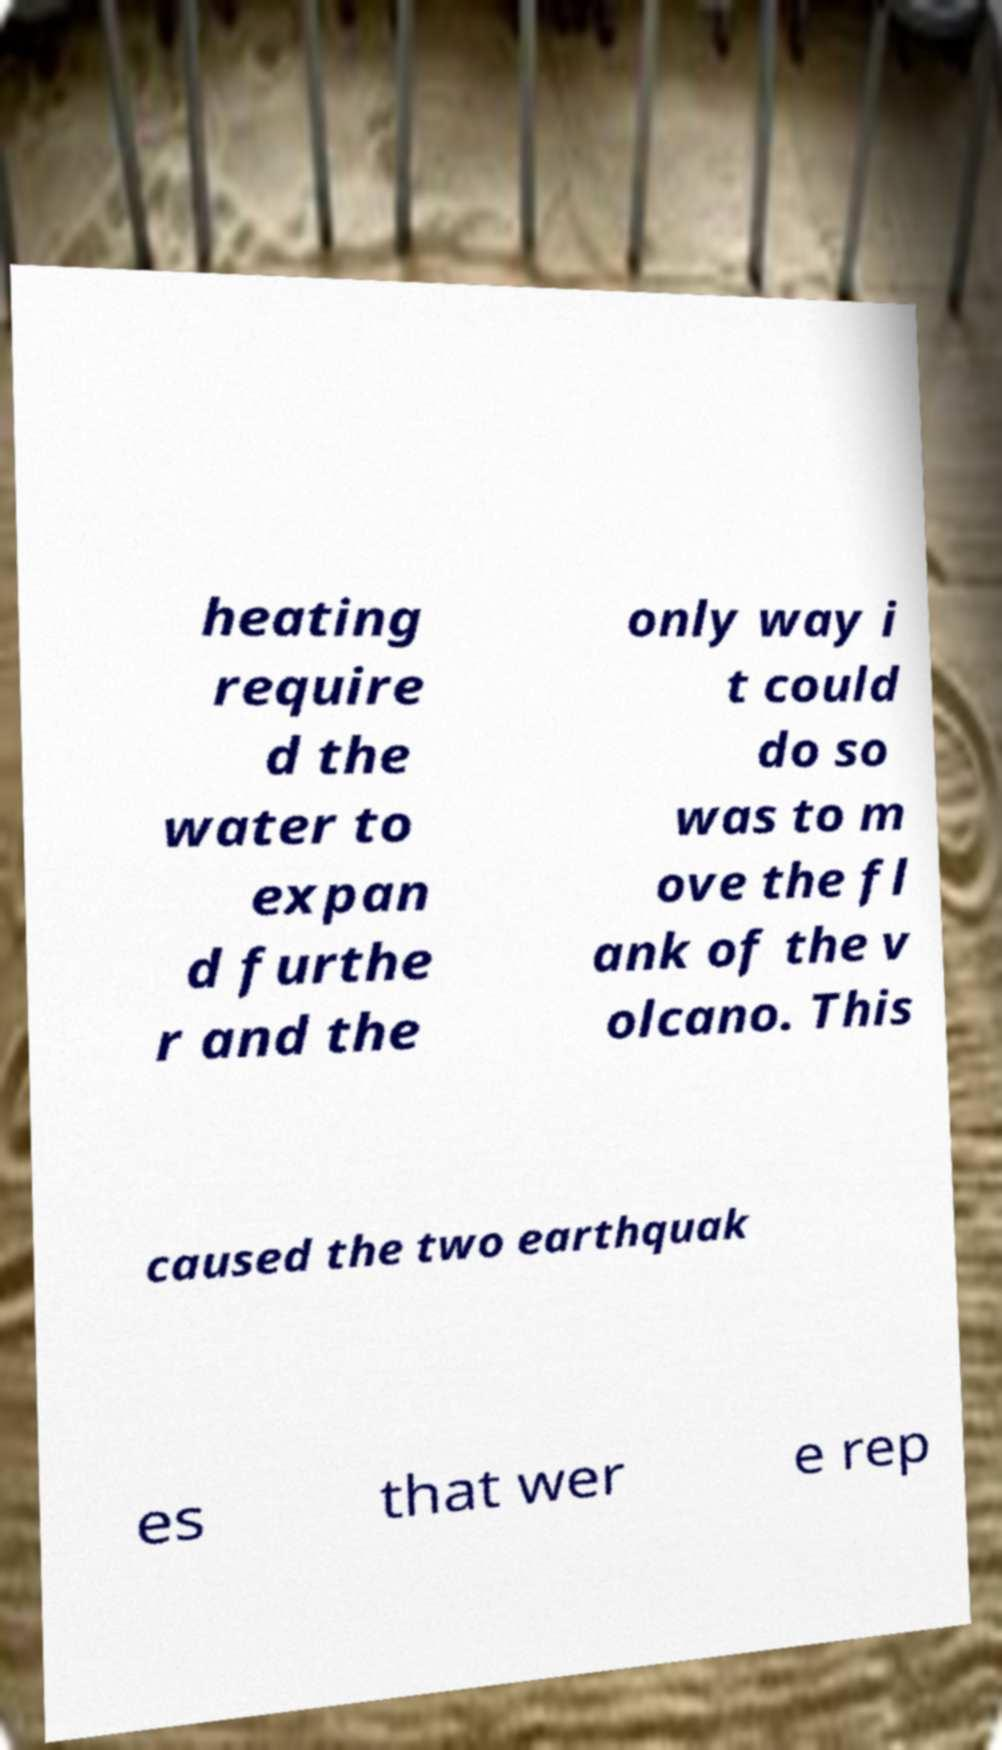Please identify and transcribe the text found in this image. heating require d the water to expan d furthe r and the only way i t could do so was to m ove the fl ank of the v olcano. This caused the two earthquak es that wer e rep 